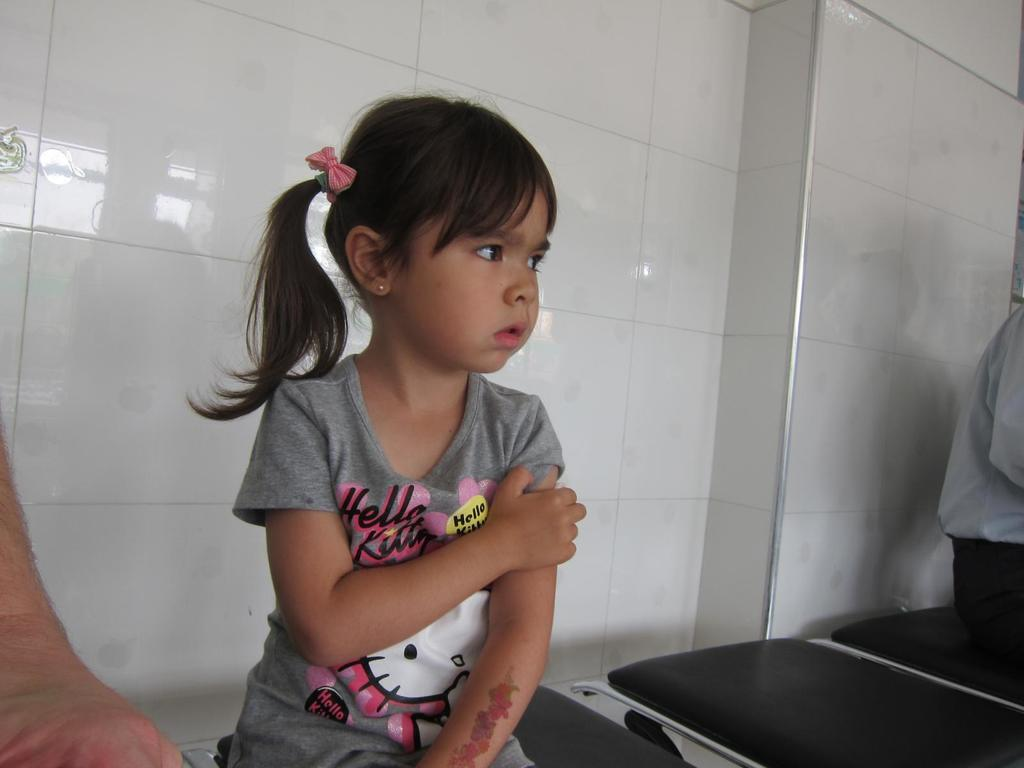Who or what is present in the image? There are people in the image. What are the people doing in the image? The people are seated on chairs. What can be seen in the background of the image? There is a wall in the background of the image. What type of berry is being used as a decoration on the wall in the image? There is no berry present in the image, nor is there any indication of decoration on the wall. 